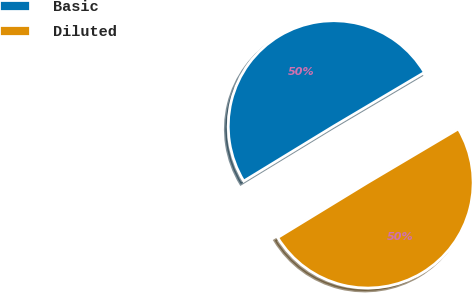Convert chart. <chart><loc_0><loc_0><loc_500><loc_500><pie_chart><fcel>Basic<fcel>Diluted<nl><fcel>50.21%<fcel>49.79%<nl></chart> 